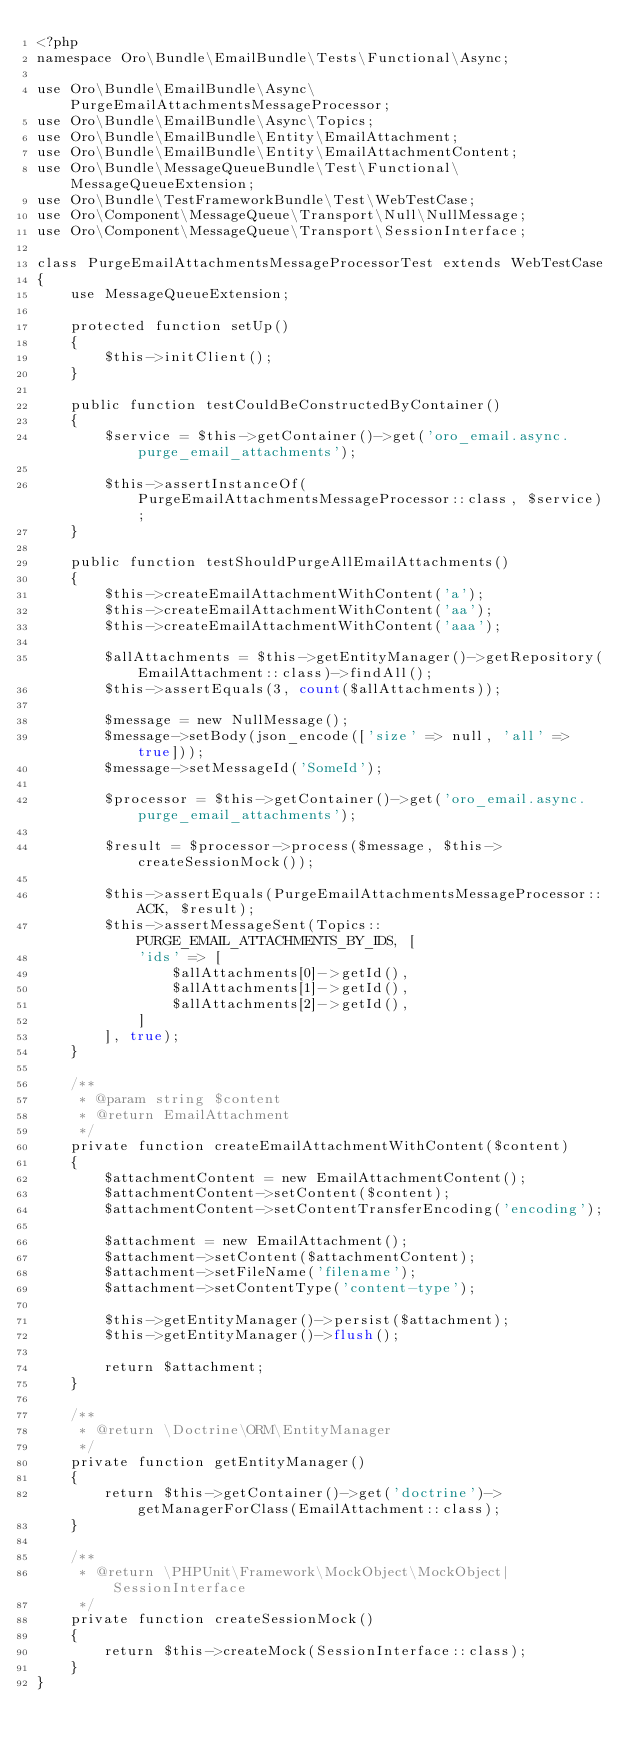Convert code to text. <code><loc_0><loc_0><loc_500><loc_500><_PHP_><?php
namespace Oro\Bundle\EmailBundle\Tests\Functional\Async;

use Oro\Bundle\EmailBundle\Async\PurgeEmailAttachmentsMessageProcessor;
use Oro\Bundle\EmailBundle\Async\Topics;
use Oro\Bundle\EmailBundle\Entity\EmailAttachment;
use Oro\Bundle\EmailBundle\Entity\EmailAttachmentContent;
use Oro\Bundle\MessageQueueBundle\Test\Functional\MessageQueueExtension;
use Oro\Bundle\TestFrameworkBundle\Test\WebTestCase;
use Oro\Component\MessageQueue\Transport\Null\NullMessage;
use Oro\Component\MessageQueue\Transport\SessionInterface;

class PurgeEmailAttachmentsMessageProcessorTest extends WebTestCase
{
    use MessageQueueExtension;

    protected function setUp()
    {
        $this->initClient();
    }

    public function testCouldBeConstructedByContainer()
    {
        $service = $this->getContainer()->get('oro_email.async.purge_email_attachments');

        $this->assertInstanceOf(PurgeEmailAttachmentsMessageProcessor::class, $service);
    }

    public function testShouldPurgeAllEmailAttachments()
    {
        $this->createEmailAttachmentWithContent('a');
        $this->createEmailAttachmentWithContent('aa');
        $this->createEmailAttachmentWithContent('aaa');

        $allAttachments = $this->getEntityManager()->getRepository(EmailAttachment::class)->findAll();
        $this->assertEquals(3, count($allAttachments));

        $message = new NullMessage();
        $message->setBody(json_encode(['size' => null, 'all' => true]));
        $message->setMessageId('SomeId');

        $processor = $this->getContainer()->get('oro_email.async.purge_email_attachments');

        $result = $processor->process($message, $this->createSessionMock());

        $this->assertEquals(PurgeEmailAttachmentsMessageProcessor::ACK, $result);
        $this->assertMessageSent(Topics::PURGE_EMAIL_ATTACHMENTS_BY_IDS, [
            'ids' => [
                $allAttachments[0]->getId(),
                $allAttachments[1]->getId(),
                $allAttachments[2]->getId(),
            ]
        ], true);
    }

    /**
     * @param string $content
     * @return EmailAttachment
     */
    private function createEmailAttachmentWithContent($content)
    {
        $attachmentContent = new EmailAttachmentContent();
        $attachmentContent->setContent($content);
        $attachmentContent->setContentTransferEncoding('encoding');

        $attachment = new EmailAttachment();
        $attachment->setContent($attachmentContent);
        $attachment->setFileName('filename');
        $attachment->setContentType('content-type');

        $this->getEntityManager()->persist($attachment);
        $this->getEntityManager()->flush();

        return $attachment;
    }

    /**
     * @return \Doctrine\ORM\EntityManager
     */
    private function getEntityManager()
    {
        return $this->getContainer()->get('doctrine')->getManagerForClass(EmailAttachment::class);
    }

    /**
     * @return \PHPUnit\Framework\MockObject\MockObject|SessionInterface
     */
    private function createSessionMock()
    {
        return $this->createMock(SessionInterface::class);
    }
}
</code> 